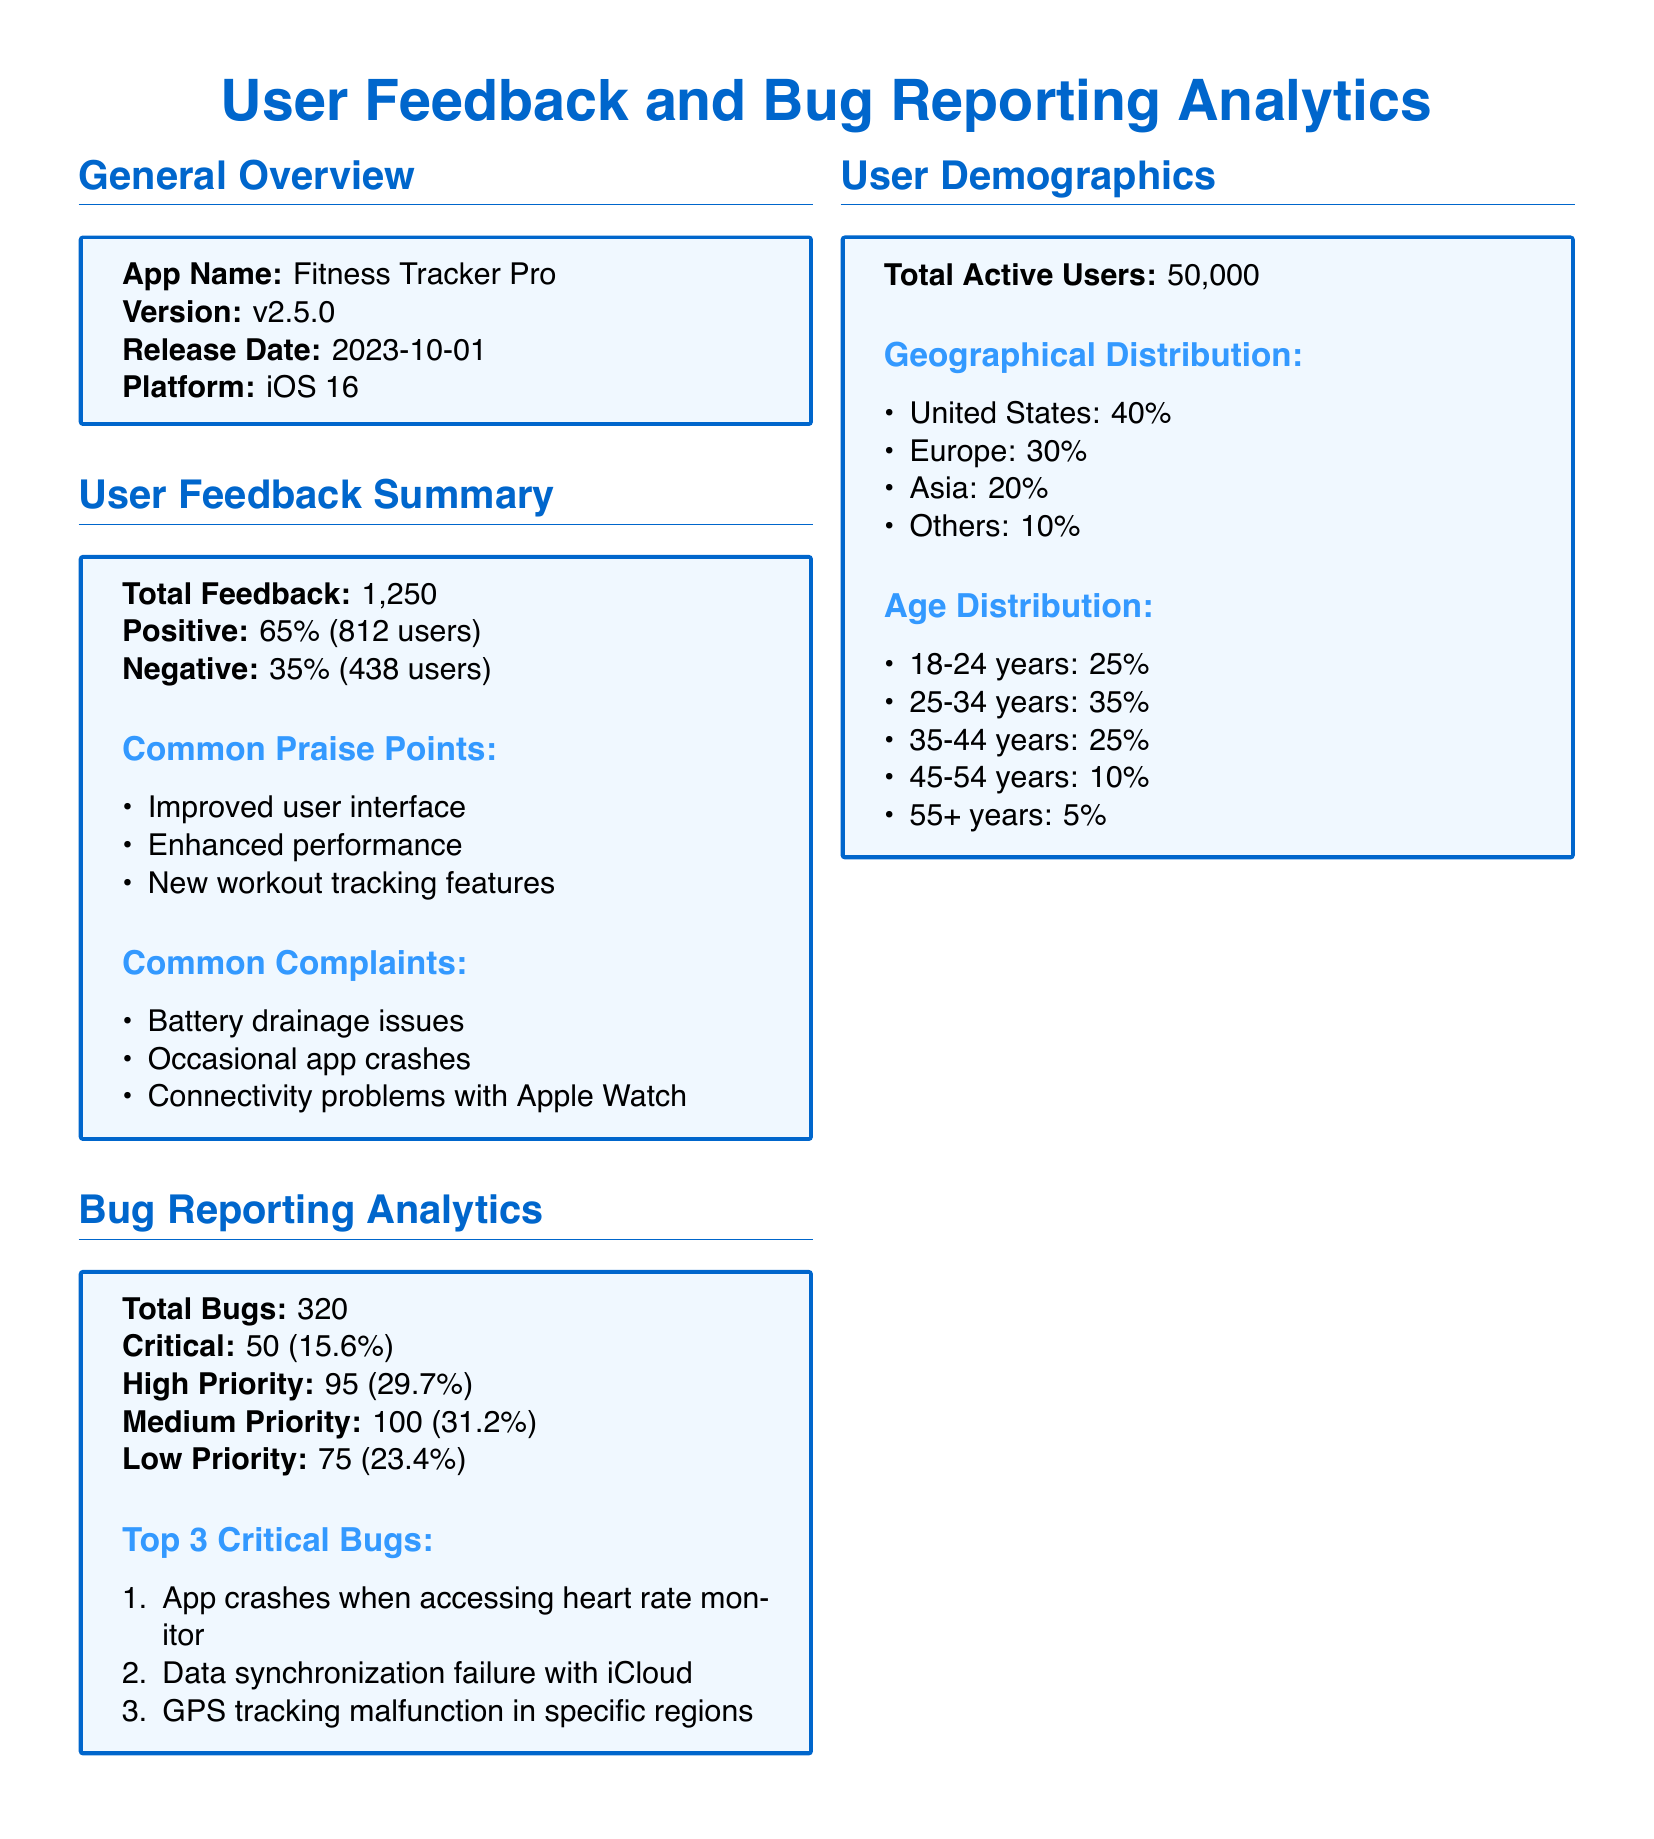What is the app name? The app name is listed in the general overview section of the document.
Answer: Fitness Tracker Pro What is the version number of the app? The version number is indicated next to the app name in the general overview section.
Answer: v2.5.0 How many total feedback responses were received? The total feedback count is provided in the user feedback summary section of the document.
Answer: 1,250 What percentage of feedback was positive? The positive feedback percentage is detailed in the user feedback summary section.
Answer: 65% What percentage of bugs reported were critical? The percentage of critical bugs is mentioned in the bug reporting analytics section.
Answer: 15.6% What are the top two geographical regions of users? The geographical distribution of users is listed in the user demographics section, highlighting the main regions.
Answer: United States, Europe Which age group has the highest representation among users? The age distribution details the percentage of users in each age group to find the highest.
Answer: 25-34 years What is the total number of active users? The total active users figure is presented in the user demographics section.
Answer: 50,000 What is one of the common complaints from users? The common complaints section lists multiple issues reported by users, and one can be cited.
Answer: Battery drainage issues What is the release date of the app? The release date is specified in the general overview section of the document.
Answer: 2023-10-01 